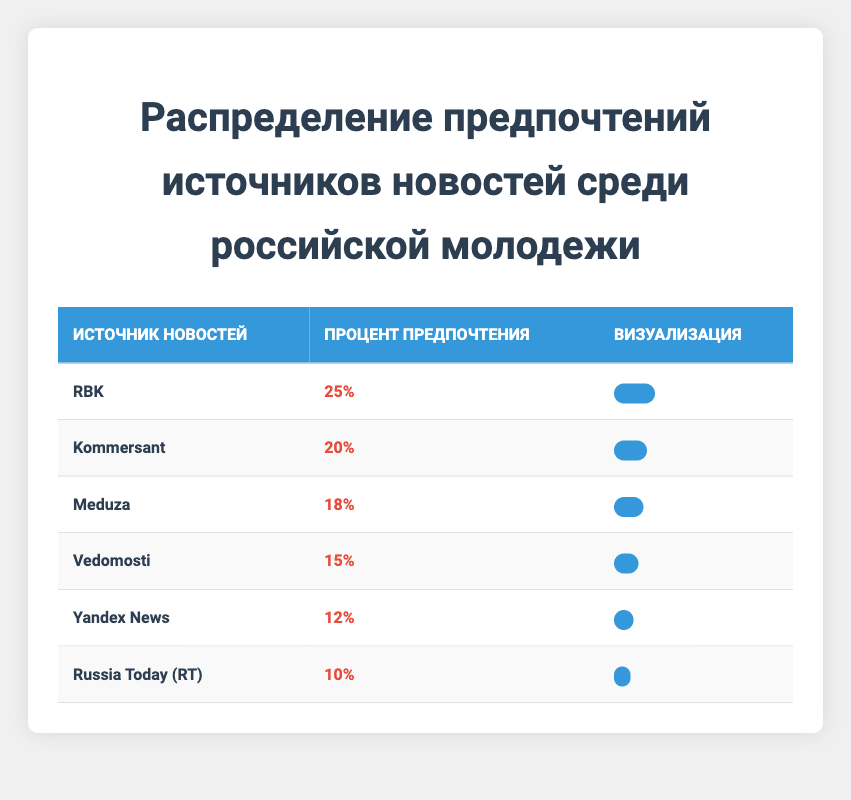What is the source preferred by the highest percentage of young adults? The table shows the percentages for each news source. RBK has a preference percentage of 25%, which is higher than any other source listed.
Answer: RBK Which news source has the lowest preference percentage? According to the table, Russia Today (RT) has the lowest preference percentage at 10%, which is the smallest value among all sources.
Answer: Russia Today (RT) What is the total preference percentage for Meduza and Vedomosti combined? To find the combined percentage, add the preference percentages of Meduza (18%) and Vedomosti (15%). This results in 18 + 15 = 33.
Answer: 33 Is the preference percentage for Yandex News greater than that of Vedomosti? The table shows that Yandex News has a preference percentage of 12%, while Vedomosti has 15%. Since 12 is less than 15, the statement is false.
Answer: No What percentage of young adults prefer either Meduza or Kommersant? Add the preference percentages of Meduza (18%) and Kommersant (20%) for a combined total of 18 + 20 = 38.
Answer: 38 Which two sources combined have a preference percentage of 20% or lower? The sources with percentages of 12% (Yandex News) and 10% (Russia Today) combine to 12 + 10 = 22%, which is greater than 20%. However, 15% (Vedomosti) and 10% (Russia Today) combined equal 25%, also greater than 20%. No combination fits.
Answer: None How many news sources have a preference percentage greater than 15%? The sources with percentages greater than 15% are RBK (25%), Kommersant (20%), and Meduza (18%). Thus, there are three sources that meet this criterion.
Answer: 3 Which news source's preference percentage is exactly half of Kommersant's? The preference percentage of Kommersant is 20%. Half of this value is 10%, which is the preference percentage for Russia Today. Therefore, Russia Today is the answer.
Answer: Russia Today 